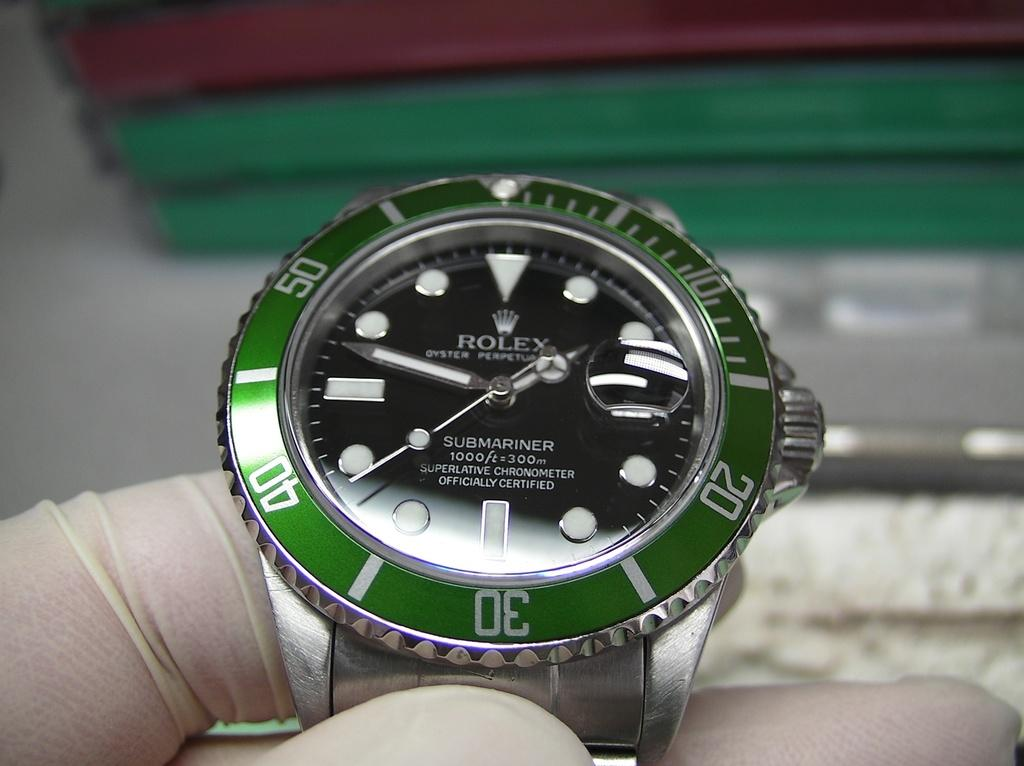What type of watch is visible in the image? There is a Rolex watch in the image. Who is holding the watch in the image? The watch is held by a person. What part of the person can be seen in the image? The person's fingers are visible in the image. How is the background of the watch depicted in the image? The background of the watch is blurred. What type of tin can be seen in the image? There is no tin present in the image. What treatment is being administered to the vegetable in the image? There is no vegetable or treatment present in the image. 